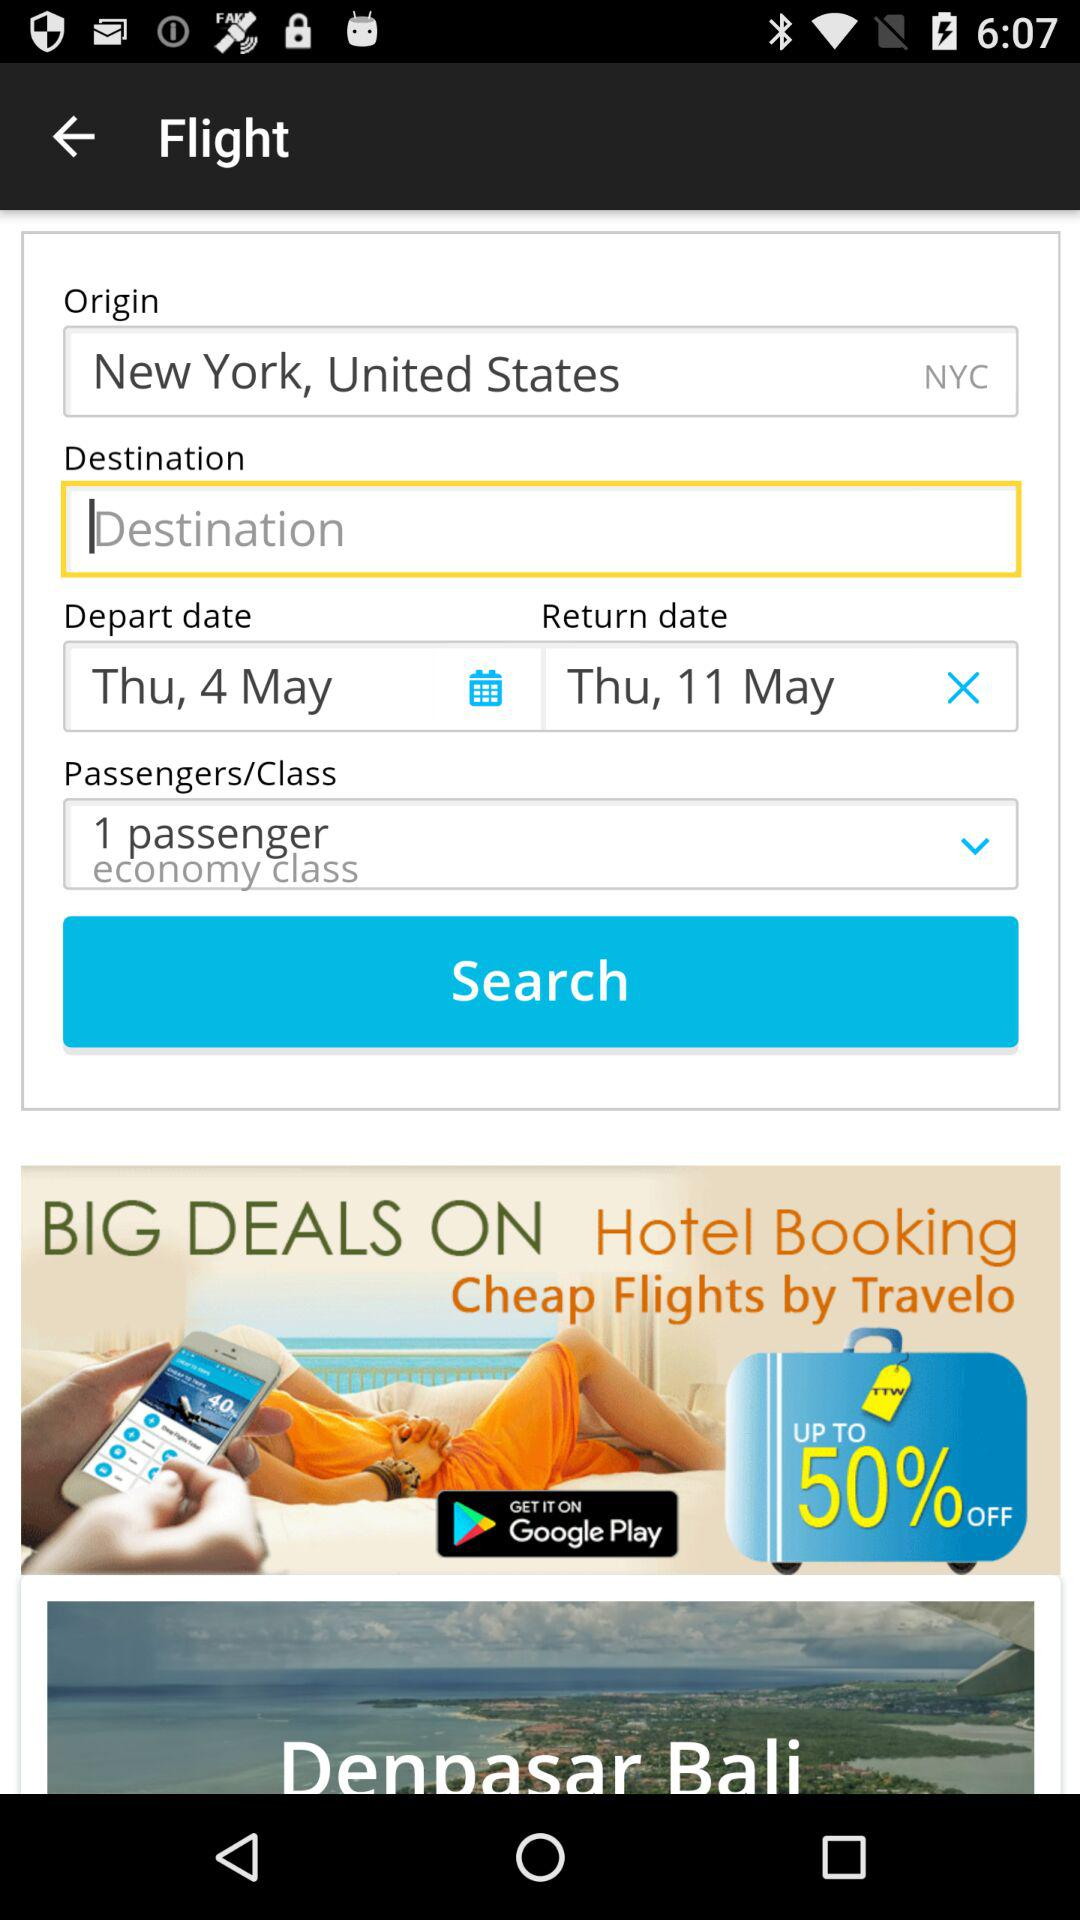What is the return date? The return date is Thursday, May 11. 